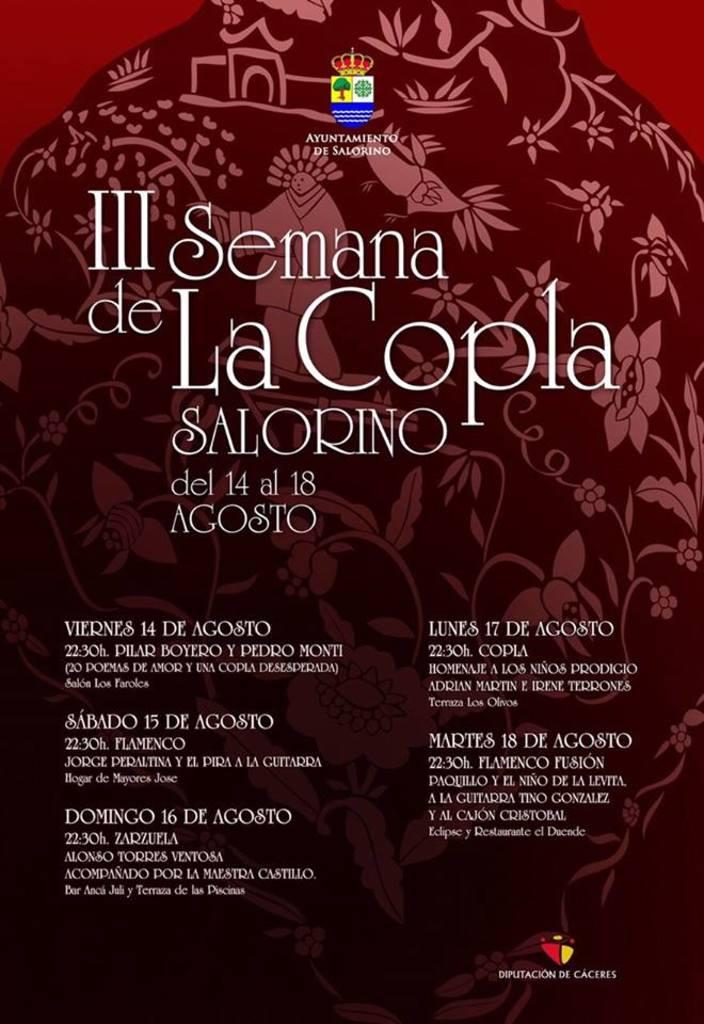<image>
Present a compact description of the photo's key features. A poster for III Semana de La Copla. 